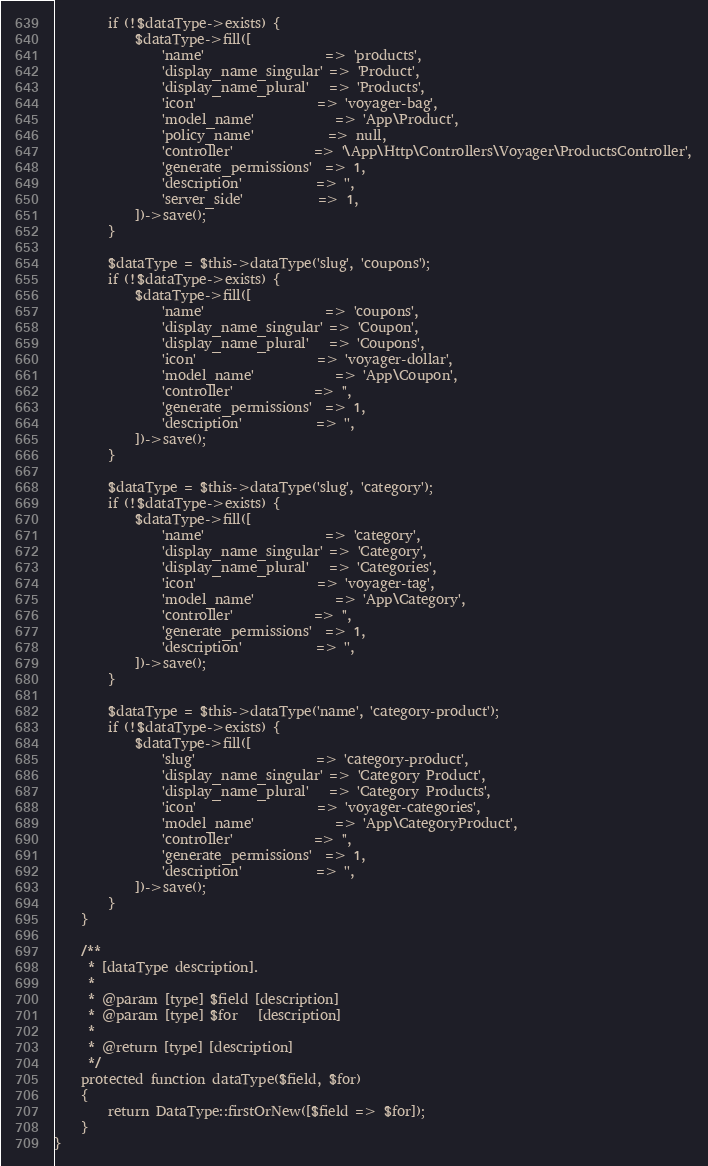Convert code to text. <code><loc_0><loc_0><loc_500><loc_500><_PHP_>        if (!$dataType->exists) {
            $dataType->fill([
                'name'                  => 'products',
                'display_name_singular' => 'Product',
                'display_name_plural'   => 'Products',
                'icon'                  => 'voyager-bag',
                'model_name'            => 'App\Product',
                'policy_name'           => null,
                'controller'            => '\App\Http\Controllers\Voyager\ProductsController',
                'generate_permissions'  => 1,
                'description'           => '',
                'server_side'           => 1,
            ])->save();
        }

        $dataType = $this->dataType('slug', 'coupons');
        if (!$dataType->exists) {
            $dataType->fill([
                'name'                  => 'coupons',
                'display_name_singular' => 'Coupon',
                'display_name_plural'   => 'Coupons',
                'icon'                  => 'voyager-dollar',
                'model_name'            => 'App\Coupon',
                'controller'            => '',
                'generate_permissions'  => 1,
                'description'           => '',
            ])->save();
        }

        $dataType = $this->dataType('slug', 'category');
        if (!$dataType->exists) {
            $dataType->fill([
                'name'                  => 'category',
                'display_name_singular' => 'Category',
                'display_name_plural'   => 'Categories',
                'icon'                  => 'voyager-tag',
                'model_name'            => 'App\Category',
                'controller'            => '',
                'generate_permissions'  => 1,
                'description'           => '',
            ])->save();
        }

        $dataType = $this->dataType('name', 'category-product');
        if (!$dataType->exists) {
            $dataType->fill([
                'slug'                  => 'category-product',
                'display_name_singular' => 'Category Product',
                'display_name_plural'   => 'Category Products',
                'icon'                  => 'voyager-categories',
                'model_name'            => 'App\CategoryProduct',
                'controller'            => '',
                'generate_permissions'  => 1,
                'description'           => '',
            ])->save();
        }
    }

    /**
     * [dataType description].
     *
     * @param [type] $field [description]
     * @param [type] $for   [description]
     *
     * @return [type] [description]
     */
    protected function dataType($field, $for)
    {
        return DataType::firstOrNew([$field => $for]);
    }
}</code> 